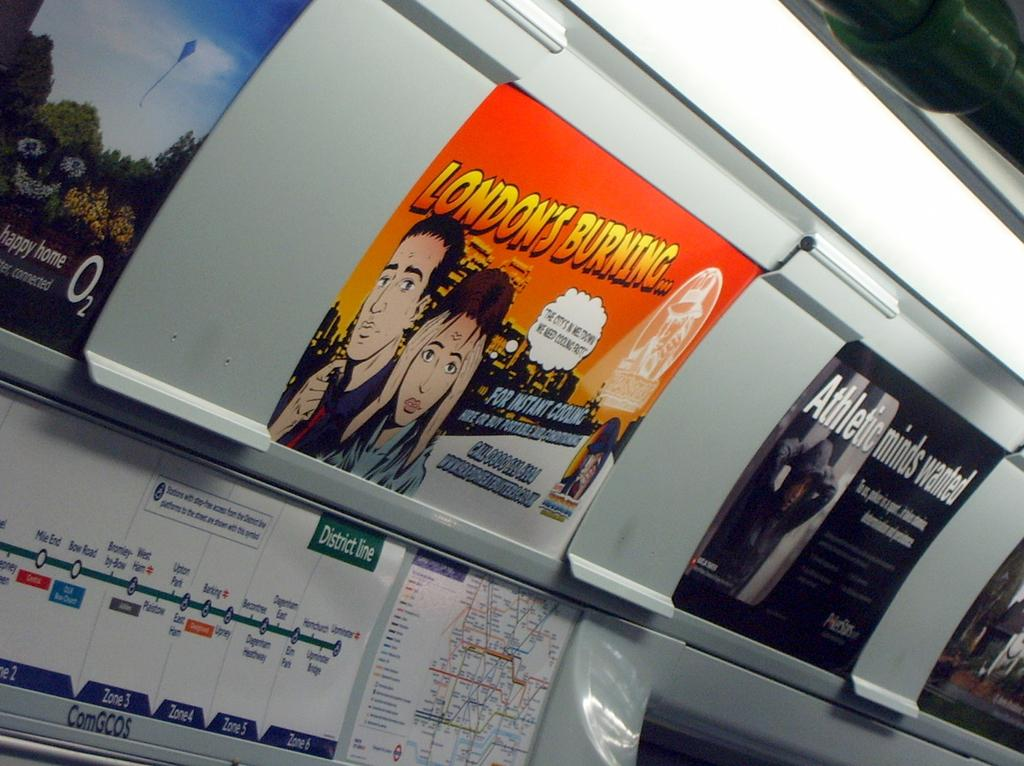<image>
Provide a brief description of the given image. A sign on a subway train that says LONDON'S BURNING and has a comic picture. 